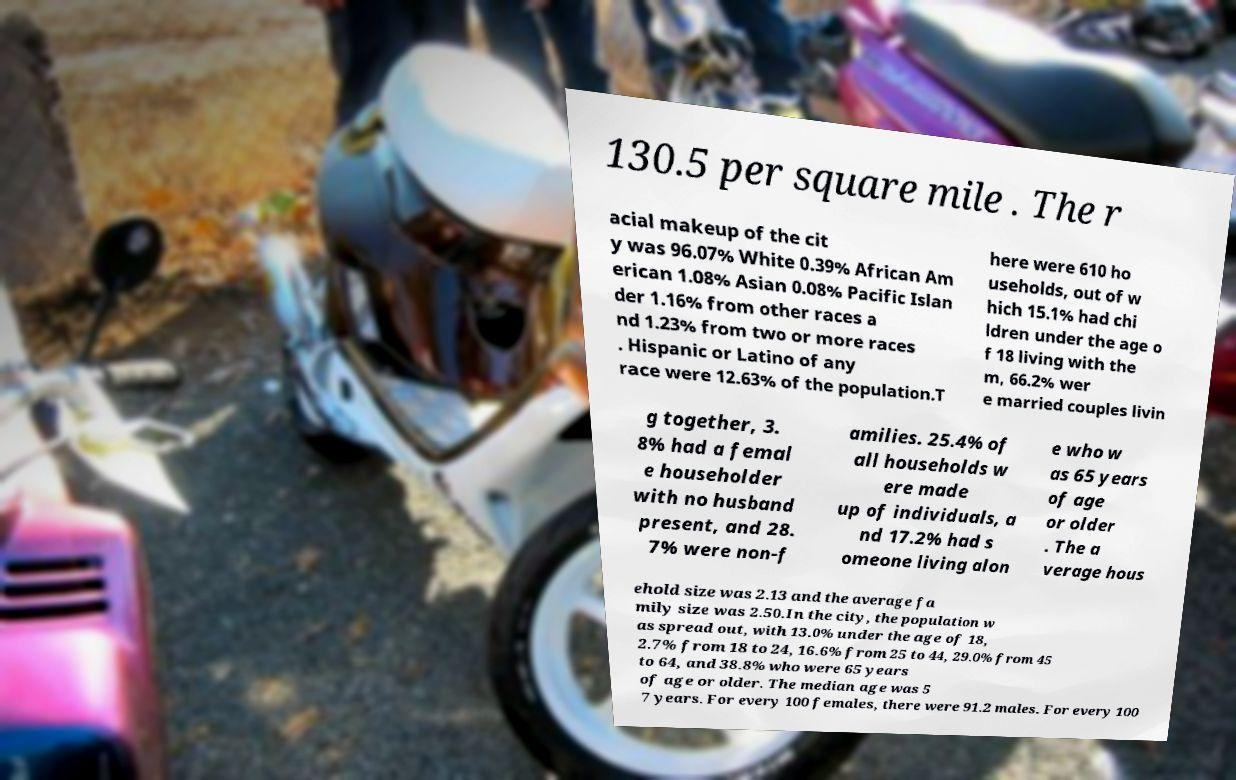What messages or text are displayed in this image? I need them in a readable, typed format. 130.5 per square mile . The r acial makeup of the cit y was 96.07% White 0.39% African Am erican 1.08% Asian 0.08% Pacific Islan der 1.16% from other races a nd 1.23% from two or more races . Hispanic or Latino of any race were 12.63% of the population.T here were 610 ho useholds, out of w hich 15.1% had chi ldren under the age o f 18 living with the m, 66.2% wer e married couples livin g together, 3. 8% had a femal e householder with no husband present, and 28. 7% were non-f amilies. 25.4% of all households w ere made up of individuals, a nd 17.2% had s omeone living alon e who w as 65 years of age or older . The a verage hous ehold size was 2.13 and the average fa mily size was 2.50.In the city, the population w as spread out, with 13.0% under the age of 18, 2.7% from 18 to 24, 16.6% from 25 to 44, 29.0% from 45 to 64, and 38.8% who were 65 years of age or older. The median age was 5 7 years. For every 100 females, there were 91.2 males. For every 100 